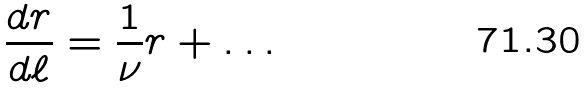<formula> <loc_0><loc_0><loc_500><loc_500>\frac { d r } { d \ell } = \frac { 1 } { \nu } r + \dots</formula> 